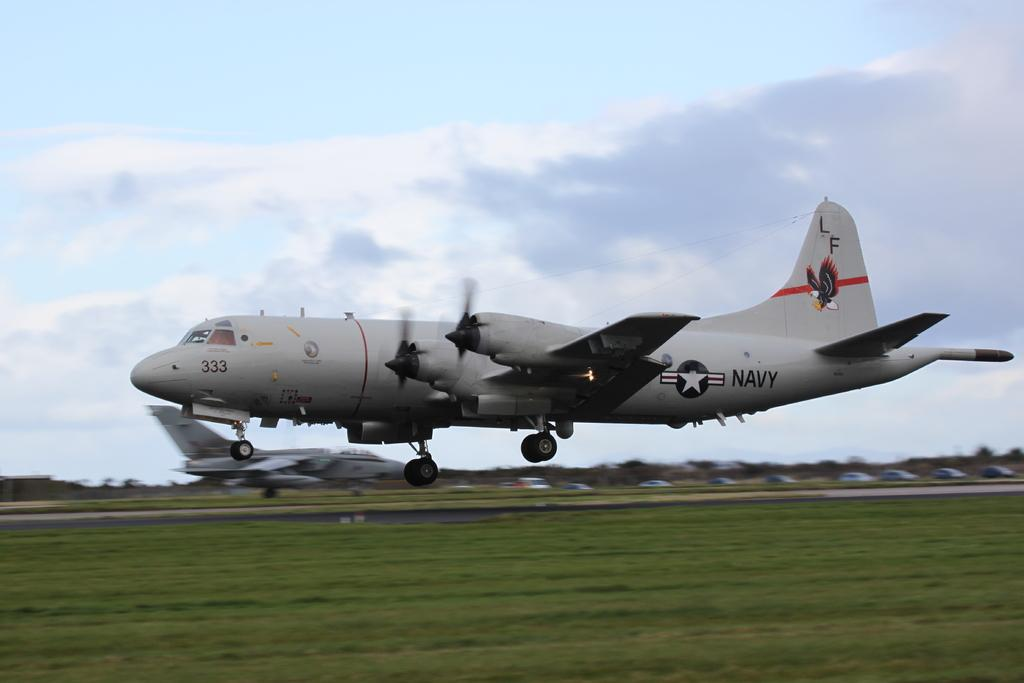Provide a one-sentence caption for the provided image. A US Navy plane has an eagle and the letters LF on the tail. 